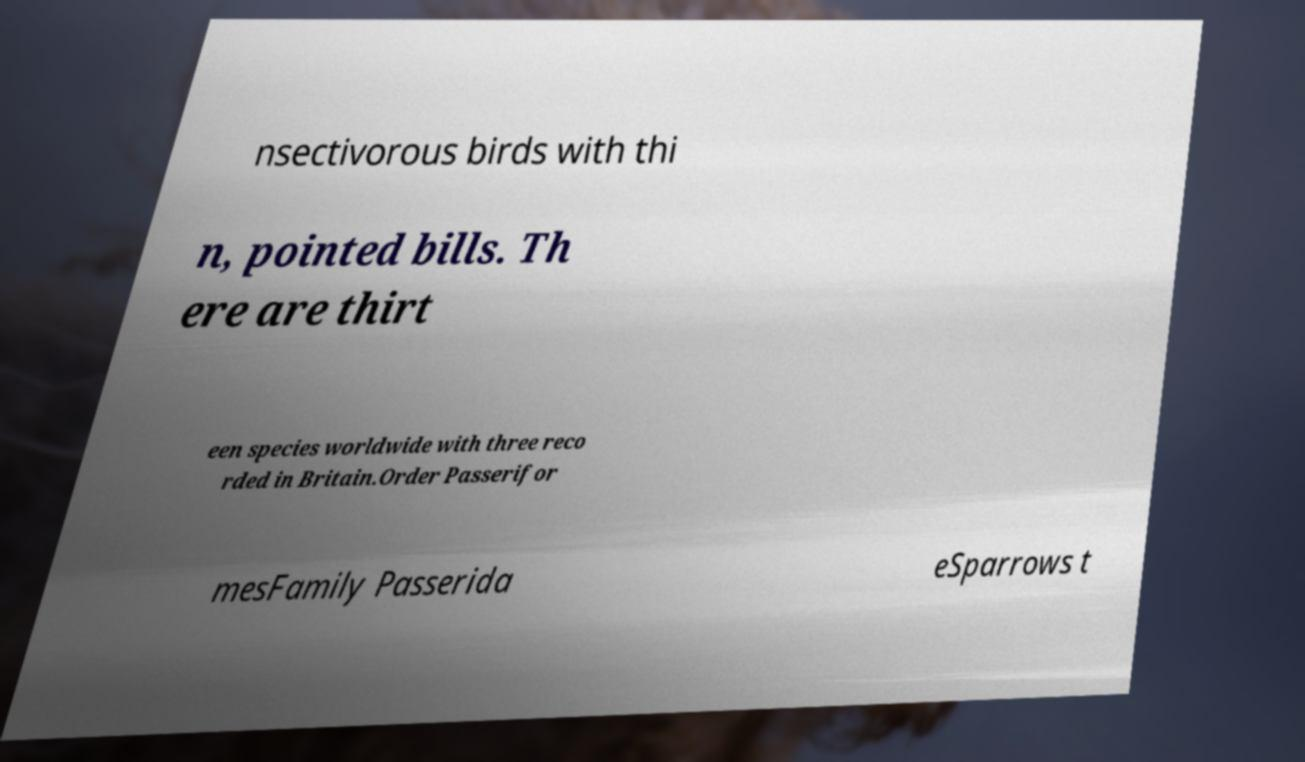There's text embedded in this image that I need extracted. Can you transcribe it verbatim? nsectivorous birds with thi n, pointed bills. Th ere are thirt een species worldwide with three reco rded in Britain.Order Passerifor mesFamily Passerida eSparrows t 